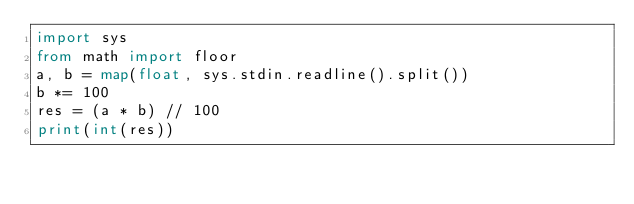<code> <loc_0><loc_0><loc_500><loc_500><_Python_>import sys
from math import floor
a, b = map(float, sys.stdin.readline().split())
b *= 100
res = (a * b) // 100
print(int(res))</code> 